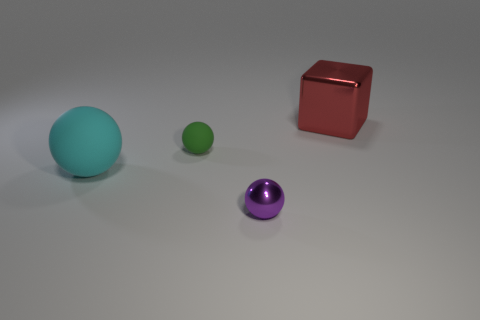How many big cyan objects are the same shape as the green matte thing?
Keep it short and to the point. 1. Is there a sphere that has the same material as the block?
Your answer should be very brief. Yes. What is the material of the small purple thing in front of the rubber ball to the left of the tiny green sphere?
Your answer should be compact. Metal. There is a shiny thing in front of the red metallic cube; what size is it?
Your answer should be very brief. Small. Does the tiny metal ball have the same color as the big thing that is behind the green thing?
Ensure brevity in your answer.  No. Is there a large rubber sphere that has the same color as the tiny matte ball?
Offer a terse response. No. Are the small green thing and the big thing that is to the left of the large cube made of the same material?
Offer a terse response. Yes. What number of tiny things are either yellow cylinders or metallic cubes?
Offer a terse response. 0. Is the number of green balls less than the number of big cyan metallic spheres?
Your response must be concise. No. There is a thing in front of the big cyan object; is its size the same as the green ball that is on the right side of the large cyan matte object?
Offer a very short reply. Yes. 